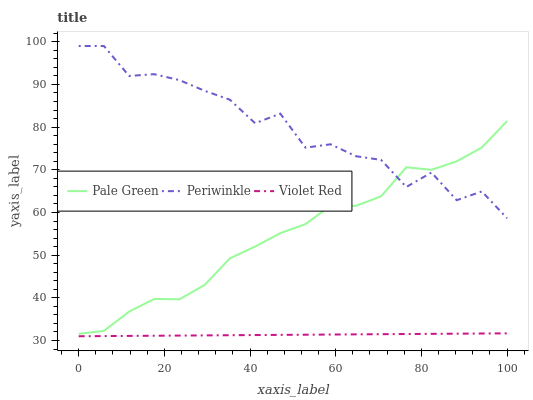Does Violet Red have the minimum area under the curve?
Answer yes or no. Yes. Does Periwinkle have the maximum area under the curve?
Answer yes or no. Yes. Does Pale Green have the minimum area under the curve?
Answer yes or no. No. Does Pale Green have the maximum area under the curve?
Answer yes or no. No. Is Violet Red the smoothest?
Answer yes or no. Yes. Is Periwinkle the roughest?
Answer yes or no. Yes. Is Pale Green the smoothest?
Answer yes or no. No. Is Pale Green the roughest?
Answer yes or no. No. Does Violet Red have the lowest value?
Answer yes or no. Yes. Does Pale Green have the lowest value?
Answer yes or no. No. Does Periwinkle have the highest value?
Answer yes or no. Yes. Does Pale Green have the highest value?
Answer yes or no. No. Is Violet Red less than Pale Green?
Answer yes or no. Yes. Is Periwinkle greater than Violet Red?
Answer yes or no. Yes. Does Pale Green intersect Periwinkle?
Answer yes or no. Yes. Is Pale Green less than Periwinkle?
Answer yes or no. No. Is Pale Green greater than Periwinkle?
Answer yes or no. No. Does Violet Red intersect Pale Green?
Answer yes or no. No. 